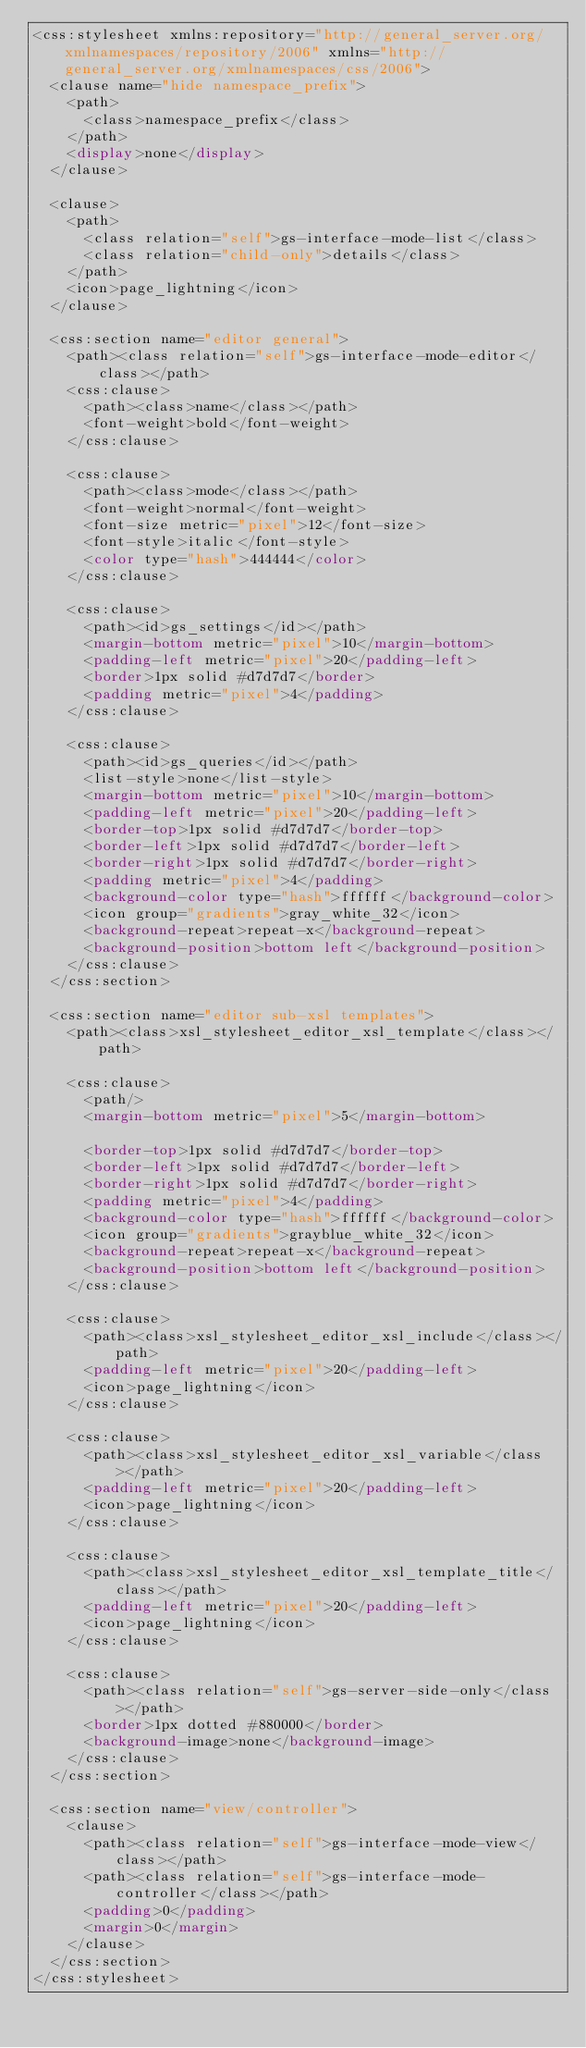<code> <loc_0><loc_0><loc_500><loc_500><_CSS_><css:stylesheet xmlns:repository="http://general_server.org/xmlnamespaces/repository/2006" xmlns="http://general_server.org/xmlnamespaces/css/2006">
  <clause name="hide namespace_prefix">
    <path>
      <class>namespace_prefix</class>
    </path>
    <display>none</display>
  </clause>

  <clause>
    <path>
      <class relation="self">gs-interface-mode-list</class>
      <class relation="child-only">details</class>
    </path>
    <icon>page_lightning</icon>
  </clause>

  <css:section name="editor general">
    <path><class relation="self">gs-interface-mode-editor</class></path>
    <css:clause>
      <path><class>name</class></path>
      <font-weight>bold</font-weight>
    </css:clause>

    <css:clause>
      <path><class>mode</class></path>
      <font-weight>normal</font-weight>
      <font-size metric="pixel">12</font-size>
      <font-style>italic</font-style>
      <color type="hash">444444</color>
    </css:clause>

    <css:clause>
      <path><id>gs_settings</id></path>
      <margin-bottom metric="pixel">10</margin-bottom>
      <padding-left metric="pixel">20</padding-left>
      <border>1px solid #d7d7d7</border>
      <padding metric="pixel">4</padding>
    </css:clause>

    <css:clause>
      <path><id>gs_queries</id></path>
      <list-style>none</list-style>
      <margin-bottom metric="pixel">10</margin-bottom>
      <padding-left metric="pixel">20</padding-left>
      <border-top>1px solid #d7d7d7</border-top>
      <border-left>1px solid #d7d7d7</border-left>
      <border-right>1px solid #d7d7d7</border-right>
      <padding metric="pixel">4</padding>
      <background-color type="hash">ffffff</background-color>
      <icon group="gradients">gray_white_32</icon>
      <background-repeat>repeat-x</background-repeat>
      <background-position>bottom left</background-position>
    </css:clause>
  </css:section>

  <css:section name="editor sub-xsl templates">
    <path><class>xsl_stylesheet_editor_xsl_template</class></path>

    <css:clause>
      <path/>
      <margin-bottom metric="pixel">5</margin-bottom>

      <border-top>1px solid #d7d7d7</border-top>
      <border-left>1px solid #d7d7d7</border-left>
      <border-right>1px solid #d7d7d7</border-right>
      <padding metric="pixel">4</padding>
      <background-color type="hash">ffffff</background-color>
      <icon group="gradients">grayblue_white_32</icon>
      <background-repeat>repeat-x</background-repeat>
      <background-position>bottom left</background-position>
    </css:clause>

    <css:clause>
      <path><class>xsl_stylesheet_editor_xsl_include</class></path>
      <padding-left metric="pixel">20</padding-left>
      <icon>page_lightning</icon>
    </css:clause>

    <css:clause>
      <path><class>xsl_stylesheet_editor_xsl_variable</class></path>
      <padding-left metric="pixel">20</padding-left>
      <icon>page_lightning</icon>
    </css:clause>

    <css:clause>
      <path><class>xsl_stylesheet_editor_xsl_template_title</class></path>
      <padding-left metric="pixel">20</padding-left>
      <icon>page_lightning</icon>
    </css:clause>

    <css:clause>
      <path><class relation="self">gs-server-side-only</class></path>
      <border>1px dotted #880000</border>
      <background-image>none</background-image>
    </css:clause>
  </css:section>

  <css:section name="view/controller">
    <clause>
      <path><class relation="self">gs-interface-mode-view</class></path>
      <path><class relation="self">gs-interface-mode-controller</class></path>
      <padding>0</padding>
      <margin>0</margin>
    </clause>
  </css:section>
</css:stylesheet></code> 